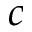Convert formula to latex. <formula><loc_0><loc_0><loc_500><loc_500>c</formula> 